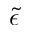<formula> <loc_0><loc_0><loc_500><loc_500>\tilde { \epsilon }</formula> 